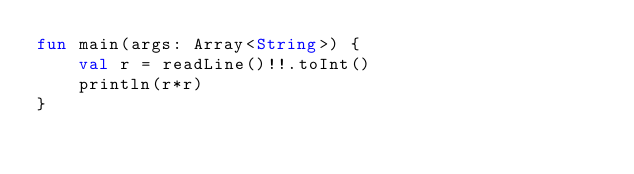Convert code to text. <code><loc_0><loc_0><loc_500><loc_500><_Kotlin_>fun main(args: Array<String>) {
    val r = readLine()!!.toInt()
    println(r*r)
}</code> 